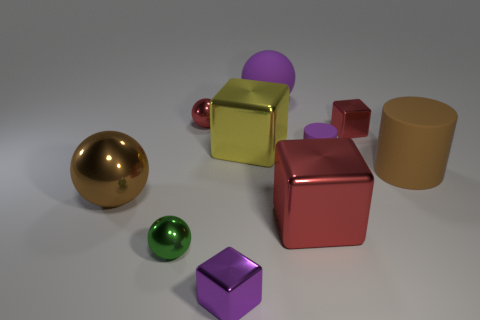Does the brown metal thing in front of the purple matte ball have the same shape as the small purple metallic thing?
Your response must be concise. No. How many green objects are matte objects or large metal spheres?
Keep it short and to the point. 0. Are there more tiny red metallic objects than green balls?
Provide a short and direct response. Yes. There is another metallic block that is the same size as the purple cube; what is its color?
Your answer should be very brief. Red. How many spheres are either red shiny objects or rubber objects?
Offer a terse response. 2. There is a tiny matte object; is its shape the same as the red metal object that is in front of the large brown shiny ball?
Provide a succinct answer. No. How many green objects are the same size as the red sphere?
Your answer should be compact. 1. Is the shape of the brown thing that is on the left side of the small green object the same as the purple rubber thing behind the purple rubber cylinder?
Provide a short and direct response. Yes. What shape is the thing that is the same color as the large shiny ball?
Your answer should be compact. Cylinder. There is a large object left of the purple object that is in front of the small purple matte cylinder; what color is it?
Give a very brief answer. Brown. 